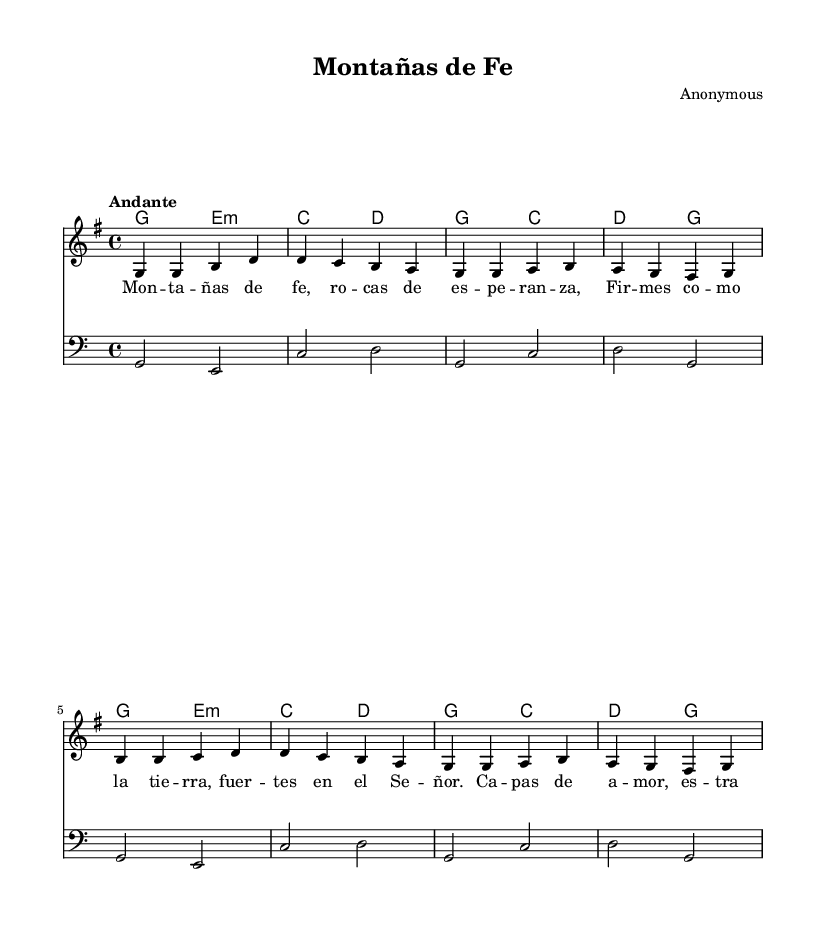What is the key signature of this music? The key signature indicated is G major, which has one sharp (F#), as shown at the beginning of the staff.
Answer: G major What is the time signature of this music? The time signature is located at the beginning of the staff and indicates four beats per measure, which is displayed as 4/4.
Answer: 4/4 What tempo is indicated for this piece? The tempo marking at the beginning states "Andante," which suggests a moderate pace for playing the music.
Answer: Andante How many measures are in the melody? By counting each group of notes separated by vertical lines, we see there are 8 measures in the melody section.
Answer: 8 What is the overall texture of this piece? The texture is determined by the presence of multiple musical lines, including melody, harmony chords, and a bass line, creating a rich sound.
Answer: Homophonic What themes are present in the lyrics of this hymn? The lyrics refer to faith, hope, love, grace, and God's majesty, embodying a religious theme of trust in the divine.
Answer: Faith and hope Which instrument is the primary focus for melody in this piece? The staff labeled "melody" directly above indicates that the primary instrument for the melody is likely a voice or instrument performing the lead line.
Answer: Voice or lead instrument 